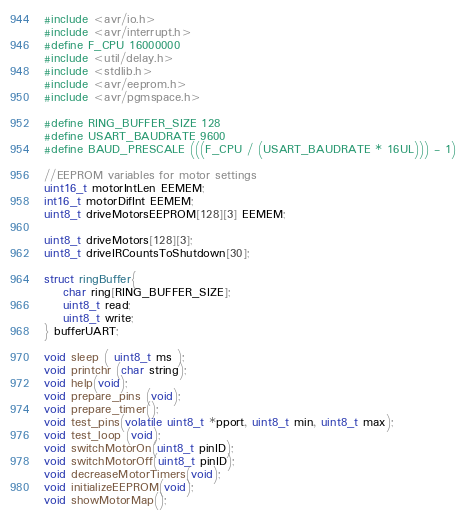Convert code to text. <code><loc_0><loc_0><loc_500><loc_500><_C_>#include <avr/io.h>
#include <avr/interrupt.h>
#define F_CPU 16000000
#include <util/delay.h>
#include <stdlib.h>
#include <avr/eeprom.h>
#include <avr/pgmspace.h>

#define RING_BUFFER_SIZE 128
#define USART_BAUDRATE 9600
#define BAUD_PRESCALE (((F_CPU / (USART_BAUDRATE * 16UL))) - 1)

//EEPROM variables for motor settings
uint16_t motorIntLen EEMEM;
int16_t motorDifInt EEMEM;
uint8_t driveMotorsEEPROM[128][3] EEMEM;

uint8_t driveMotors[128][3];
uint8_t driveIRCountsToShutdown[30];

struct ringBuffer{
	char ring[RING_BUFFER_SIZE];
	uint8_t read;
	uint8_t write;
} bufferUART;

void sleep ( uint8_t ms );
void printchr (char string);
void help(void);
void prepare_pins (void);
void prepare_timer();
void test_pins(volatile uint8_t *pport, uint8_t min, uint8_t max);
void test_loop (void);
void switchMotorOn(uint8_t pinID);
void switchMotorOff(uint8_t pinID);
void decreaseMotorTimers(void);
void initializeEEPROM(void);
void showMotorMap();</code> 